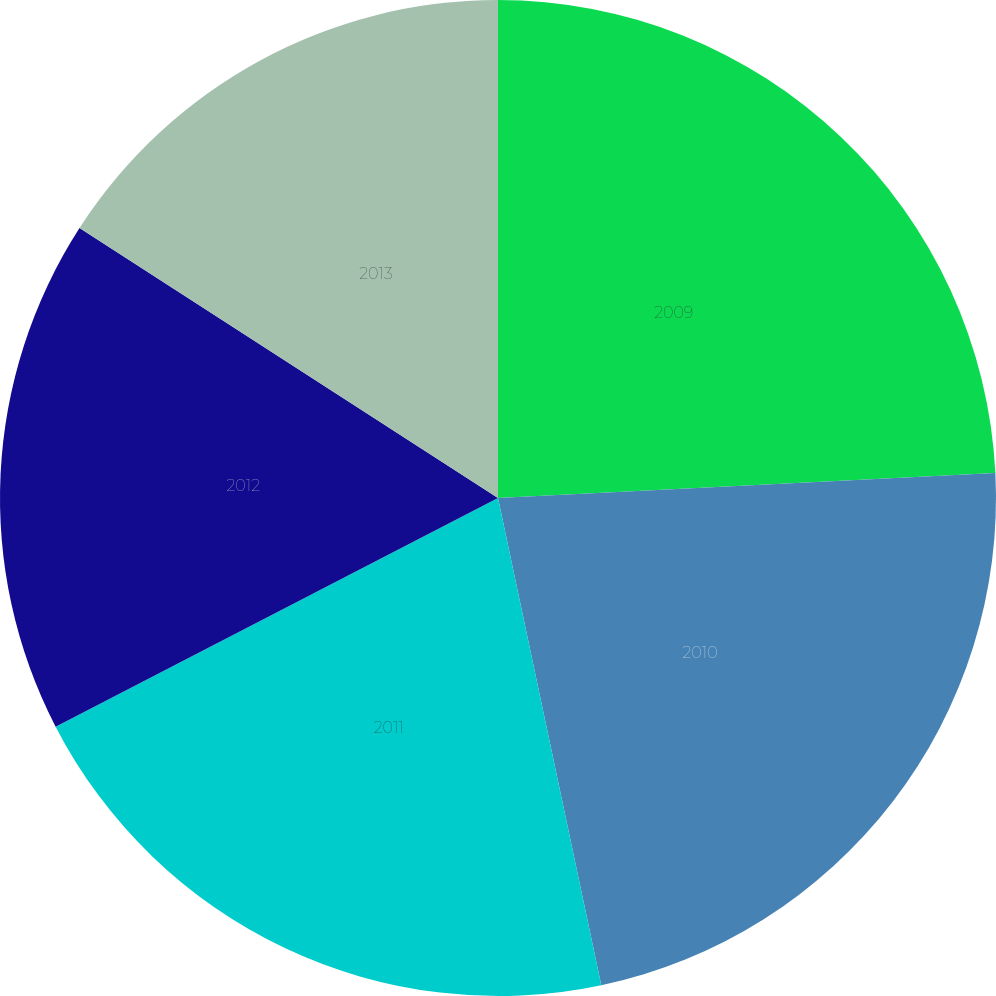<chart> <loc_0><loc_0><loc_500><loc_500><pie_chart><fcel>2009<fcel>2010<fcel>2011<fcel>2012<fcel>2013<nl><fcel>24.2%<fcel>22.47%<fcel>20.73%<fcel>16.71%<fcel>15.88%<nl></chart> 